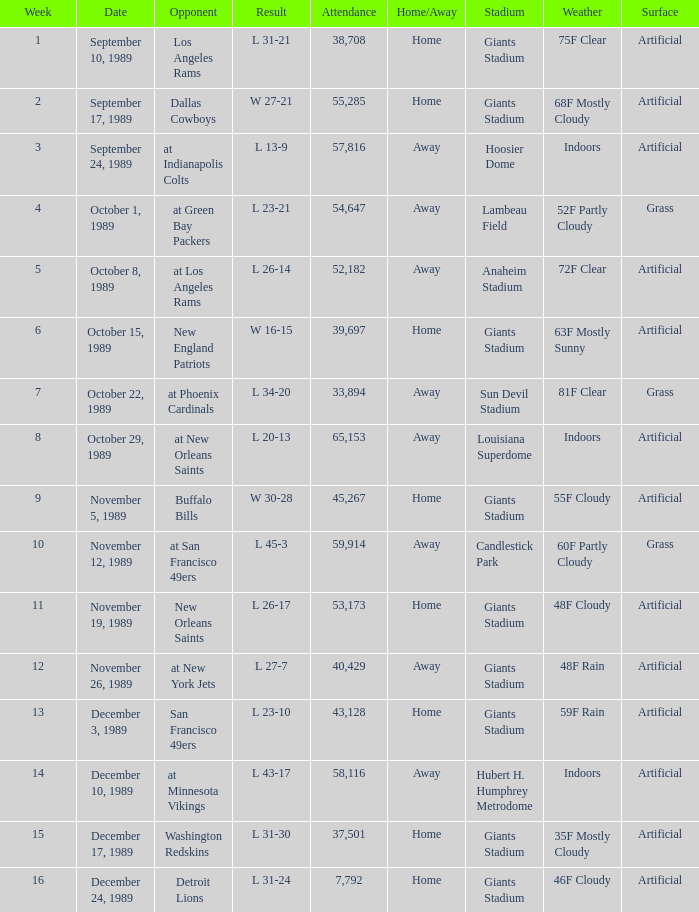On September 10, 1989 how many people attended the game? 38708.0. 